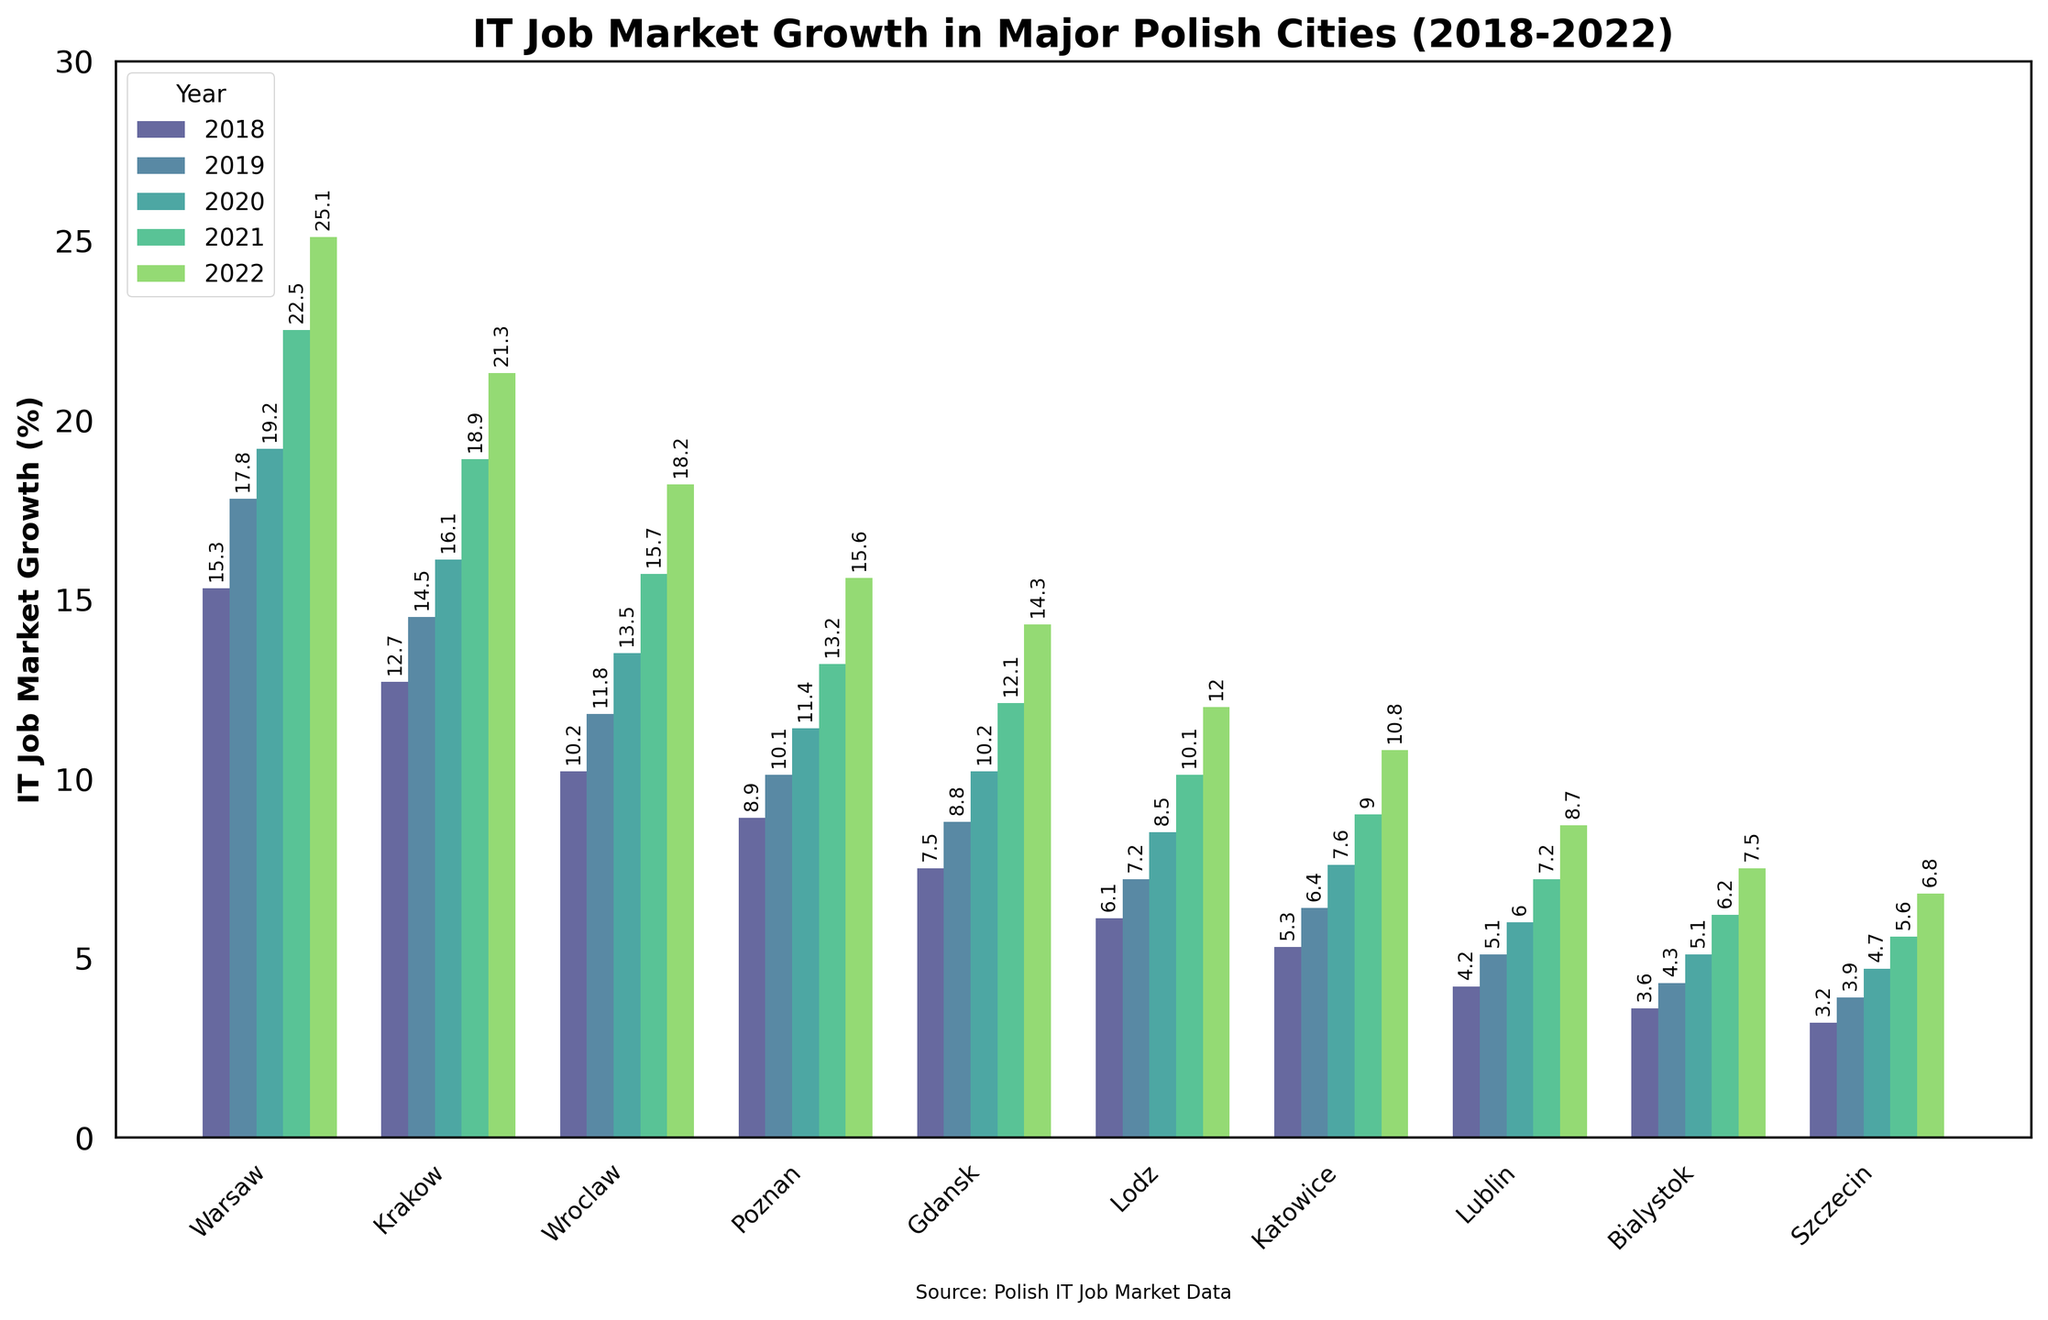What's the fastest growing city in the Polish IT job market between 2018 and 2022? To find the fastest-growing city, we need to look at the overall growth percentages from 2018 to 2022 for each city. Warsaw seems to have the highest increase from 15.3% to 25.1%, totaling a growth of 9.8%.
Answer: Warsaw Which city experienced the slowest growth in the IT job market from 2018 to 2022? We look for the city with the smallest overall growth percentage from 2018 to 2022. The city with the lowest increase is Szczecin with a growth from 3.2% to 6.8%, totaling a 3.6% increase.
Answer: Szczecin How much more did the IT job market in Krakow grow compared to Poznan in 2022? We need to compare the 2022 data points for Krakow and Poznan. Krakow grew by 21.3% in 2022, and Poznan grew by 15.6%. The difference is 21.3% - 15.6% = 5.7%.
Answer: 5.7% Which city saw the highest increase in IT job growth from 2021 to 2022? We compare the data from 2021 and 2022 for each city. Warsaw had an increase from 22.5% in 2021 to 25.1% in 2022, an increase of 2.6%, which is the highest among all cities.
Answer: Warsaw Between 2018 and 2022, which city had the most consistent growth in IT job market percentages? To determine consistent growth, we look at the increments in each year for each city and see which city has the smallest variation in yearly growth rates. For instance, Lublin's yearly growth from 2018 to 2022 is 0.9%, 0.9%, 1.2%, 1.5%, which appears to be quite consistent.
Answer: Lublin Which year shows the most significant overall growth for most cities? We should sum each city's growth for all years and compare. The year with the most significant overall growth would have the highest sum of growth values among the cities. From visual inspection of the heights of the bars, 2022 appears to show the most significant growth in many cities, indicating it is the highest.
Answer: 2022 What is the average IT job market growth in 2022 for all cities? We add up the 2022 data points for all cities and divide by the number of cities: (25.1% + 21.3% + 18.2% + 15.6% + 14.3% + 12.0% + 10.8% + 8.7% + 7.5% + 6.8%) / 10 = 14.03%.
Answer: 14.03% Which city had the smallest year-over-year growth from 2020 to 2021? We compare the growth increments for each city from 2020 to 2021. Szczecin's increase from 4.7% in 2020 to 5.6% in 2021, which is just 0.9%, appears to be the smallest growth.
Answer: Szczecin What is the total increase in IT job market growth for Wroclaw from 2018 to 2022? To find the total increase, subtract the 2018 data point from the 2022 data point for Wroclaw. The increase is 18.2% - 10.2% = 8.0%.
Answer: 8.0% The height of which city's bar is the highest in 2022, and what does it represent? The highest bar in 2022 belongs to Warsaw, representing the IT job market growth percentage, which stands at 25.1%.
Answer: Warsaw, 25.1% 